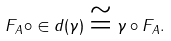<formula> <loc_0><loc_0><loc_500><loc_500>F _ { A } \circ \in d ( \gamma ) \cong \gamma \circ F _ { A } .</formula> 